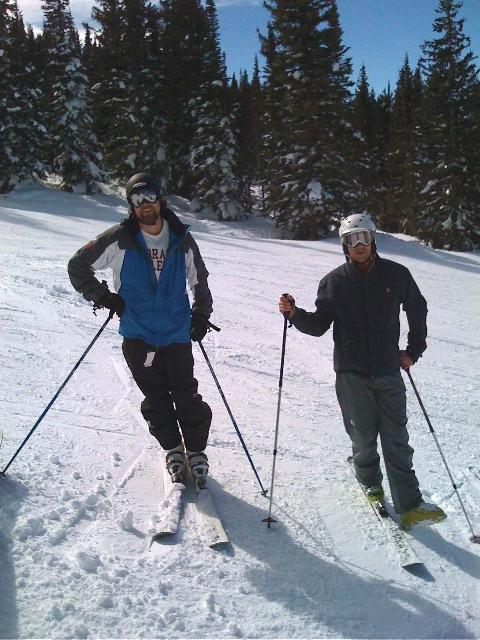How many people are holding ski poles? two 